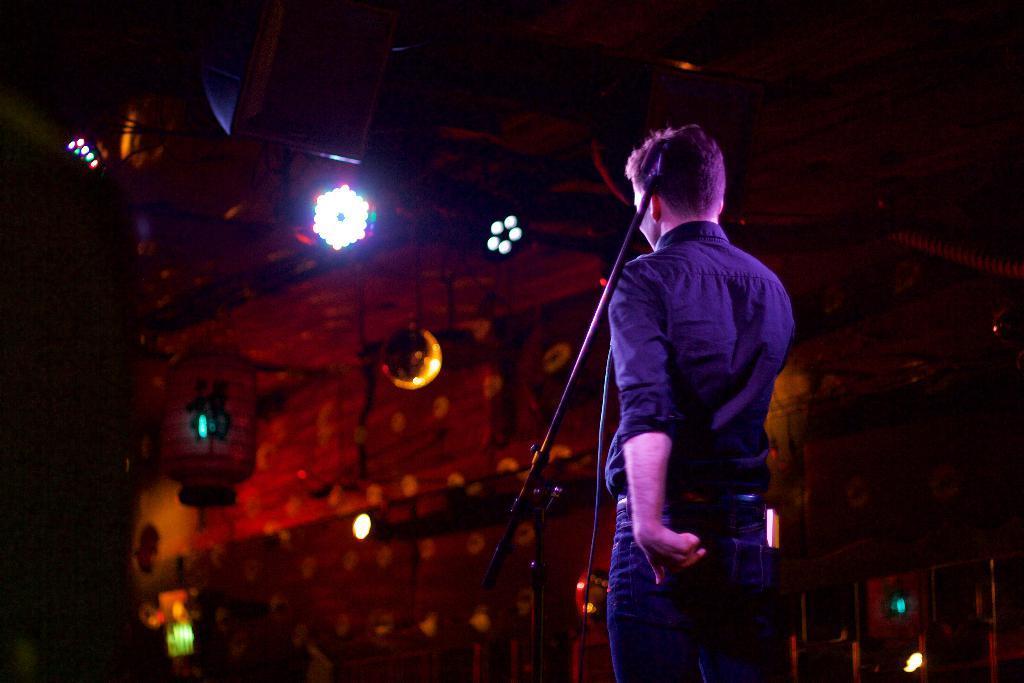Please provide a concise description of this image. In this image there is a person standing in front of the mic, in the background there is a wall with some lights. 